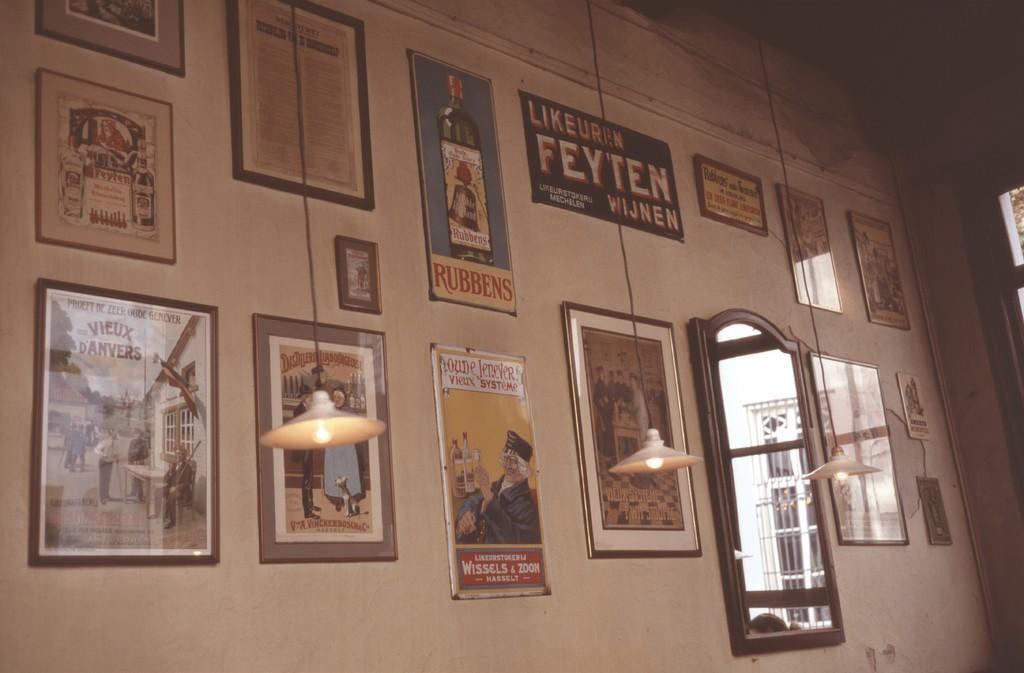How would you summarize this image in a sentence or two? In this picture we can see there are photo frames, boards and a mirror on the wall. In front of the wall there are three lights hanged. On the mirror we can see the reflection of a window. 